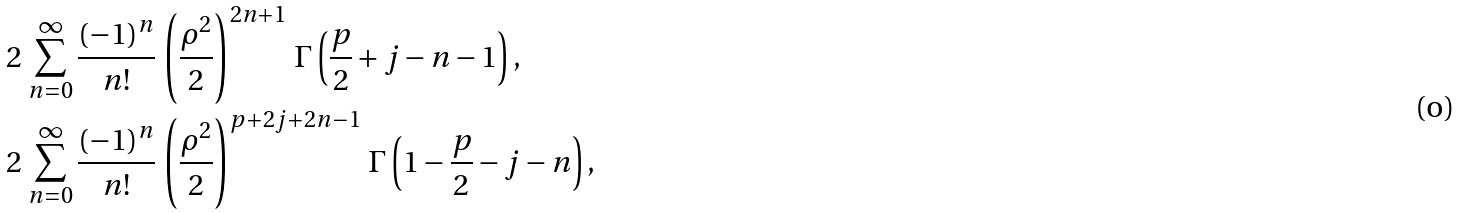Convert formula to latex. <formula><loc_0><loc_0><loc_500><loc_500>& 2 \, \sum _ { n = 0 } ^ { \infty } \frac { ( - 1 ) ^ { n } } { n ! } \, \left ( \frac { \rho ^ { 2 } } { 2 } \right ) ^ { 2 n + 1 } \, \Gamma \left ( \frac { p } { 2 } + j - n - 1 \right ) , \\ & 2 \, \sum _ { n = 0 } ^ { \infty } \frac { ( - 1 ) ^ { n } } { n ! } \, \left ( \frac { \rho ^ { 2 } } { 2 } \right ) ^ { p + 2 j + 2 n - 1 } \, \Gamma \left ( 1 - \frac { p } { 2 } - j - n \right ) ,</formula> 